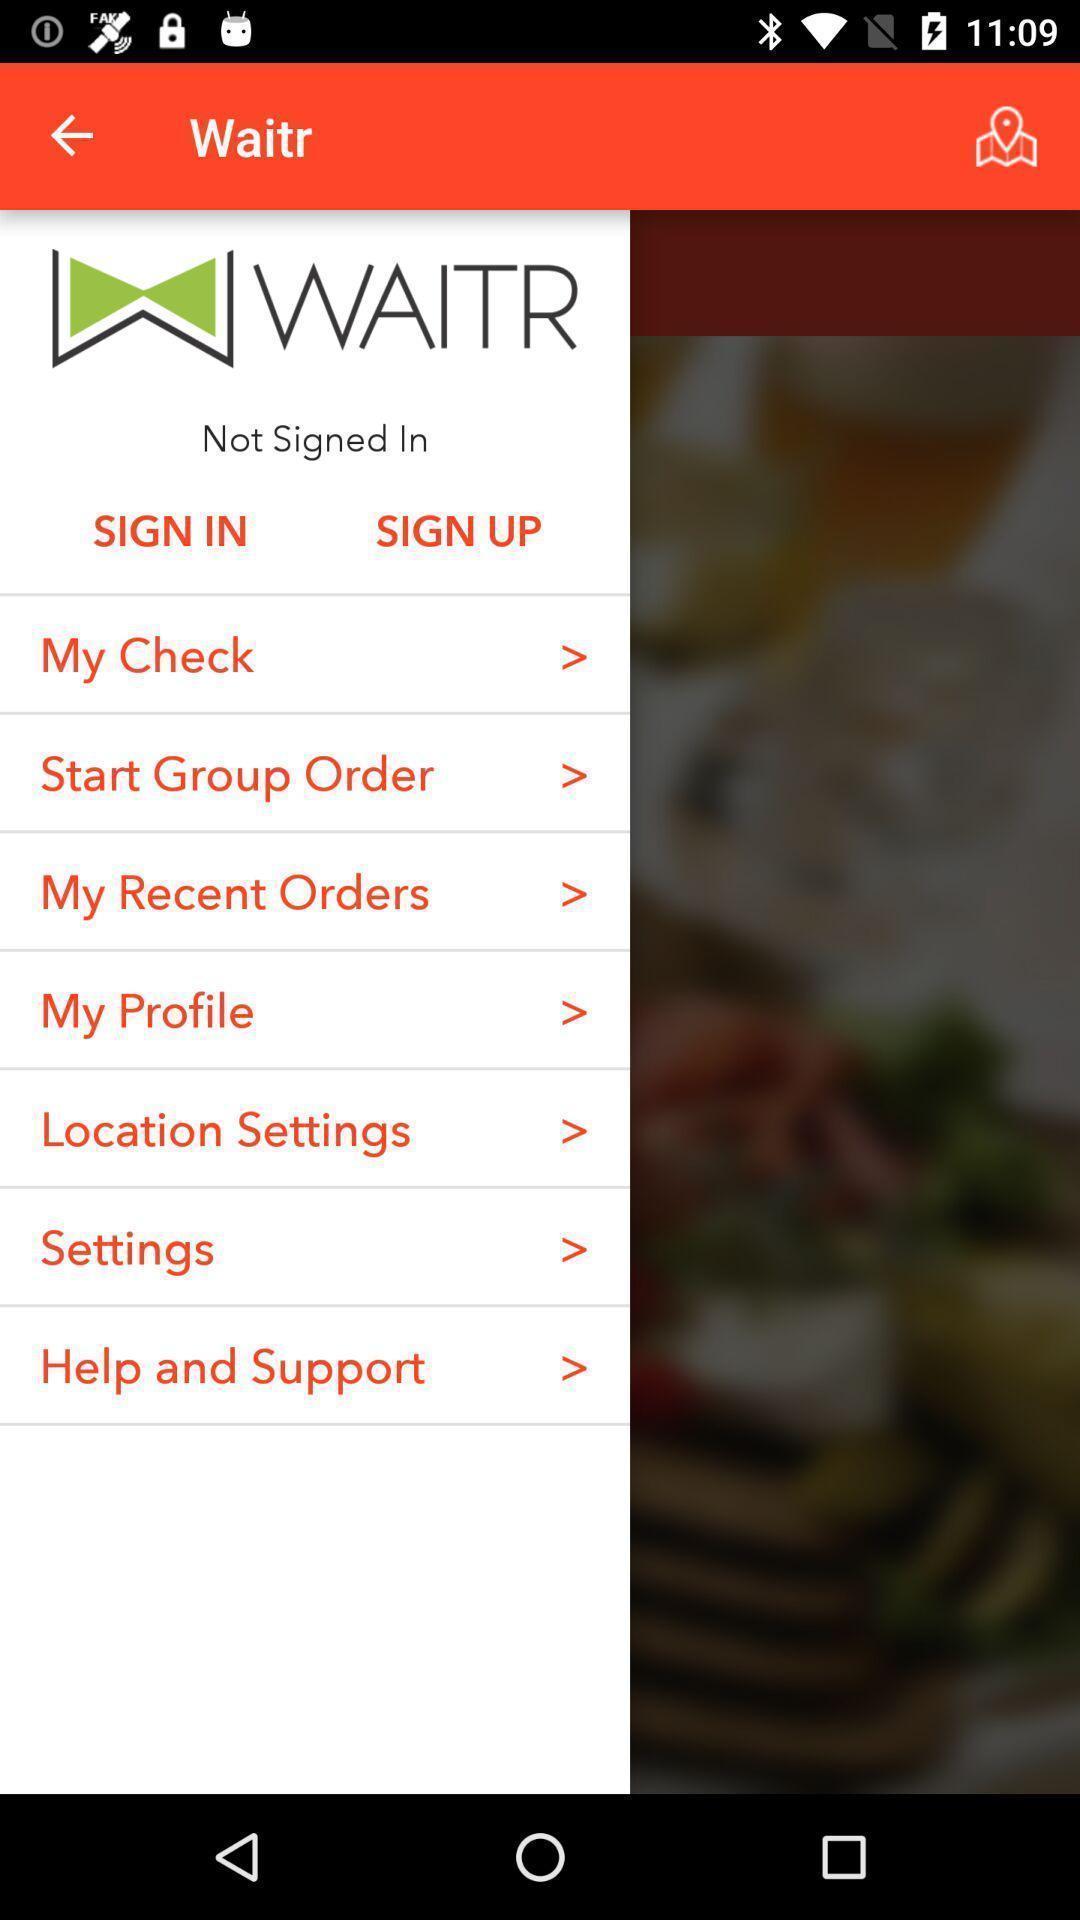Provide a detailed account of this screenshot. Starting page of the application with slide to display. 